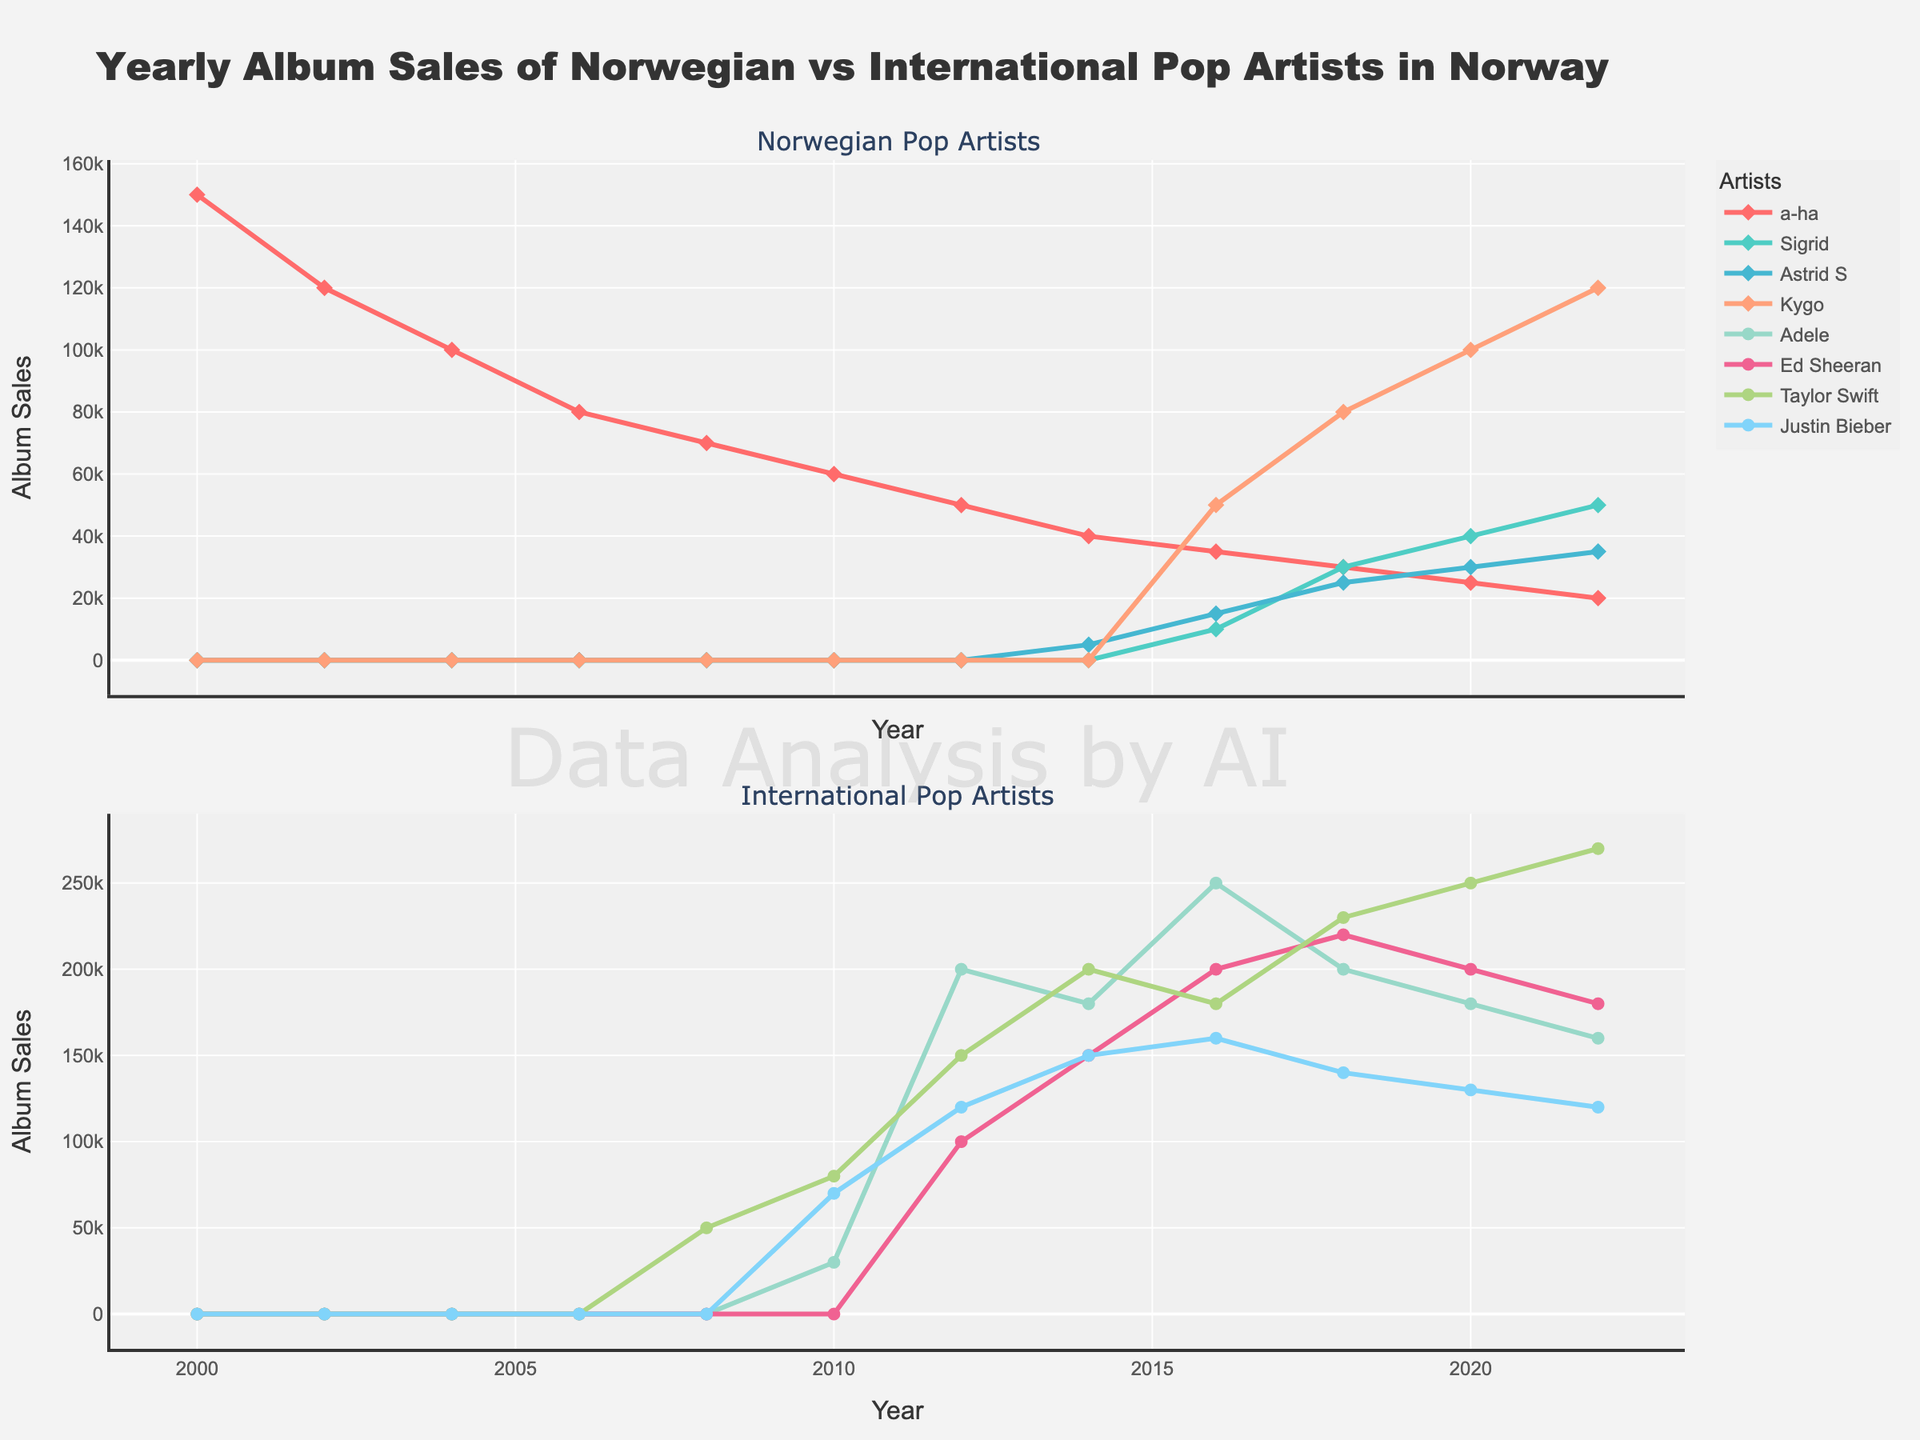What is the title of the figure? The title of the figure is usually shown at the top. In this case, the title stated is "Yearly Album Sales of Norwegian vs International Pop Artists in Norway".
Answer: Yearly Album Sales of Norwegian vs International Pop Artists in Norway How many albums did a-ha sell in 2000? You can find this by looking at the first data point on the line representing a-ha, which corresponds to the year 2000. The y-axis value for that point is 150000.
Answer: 150000 Which international artist sold the most albums in 2012? To determine this, look for the highest data point on the relevant lines for international artists in 2012. Adele's line reaches the highest value at 200000.
Answer: Adele How do the album sales of Sigrid and Kygo compare in 2018? In 2018, Sigrid's album sales are represented by the line and point at 30000, while Kygo's album sales are represented by the line and point at 80000. Thus, Kygo sold more albums.
Answer: Kygo sold more What is the trend of a-ha's album sales from 2000 to 2022? Observe the line representing a-ha throughout the years. It shows a consistent decreasing trend from 150000 in 2000 to 20000 in 2022.
Answer: Decreasing trend How many years did Astrid S have higher album sales than Sigrid? By comparing the lines for Astrid S and Sigrid at each given year, we find that Astrid S had higher sales in 2016.
Answer: 1 year What is the overall trend of international pop artists' album sales in Norway since 2008? Examining the lines for international artists from 2008 onwards, one can see an upward trend as album sales generally increased for artists like Adele, Ed Sheeran, and Taylor Swift.
Answer: Increasing trend Which artist had the highest album sales in 2020? Check the y-values for all artists in 2020 and compare them. Taylor Swift had the highest sales with 250000.
Answer: Taylor Swift Between 2004 and 2006, did a-ha's album sales decrease or increase, and by how much? Look at the points for a-ha in 2004 and 2006. The sales decreased from 100000 in 2004 to 80000 in 2006, a decrease of 20000.
Answer: Decreased by 20000 